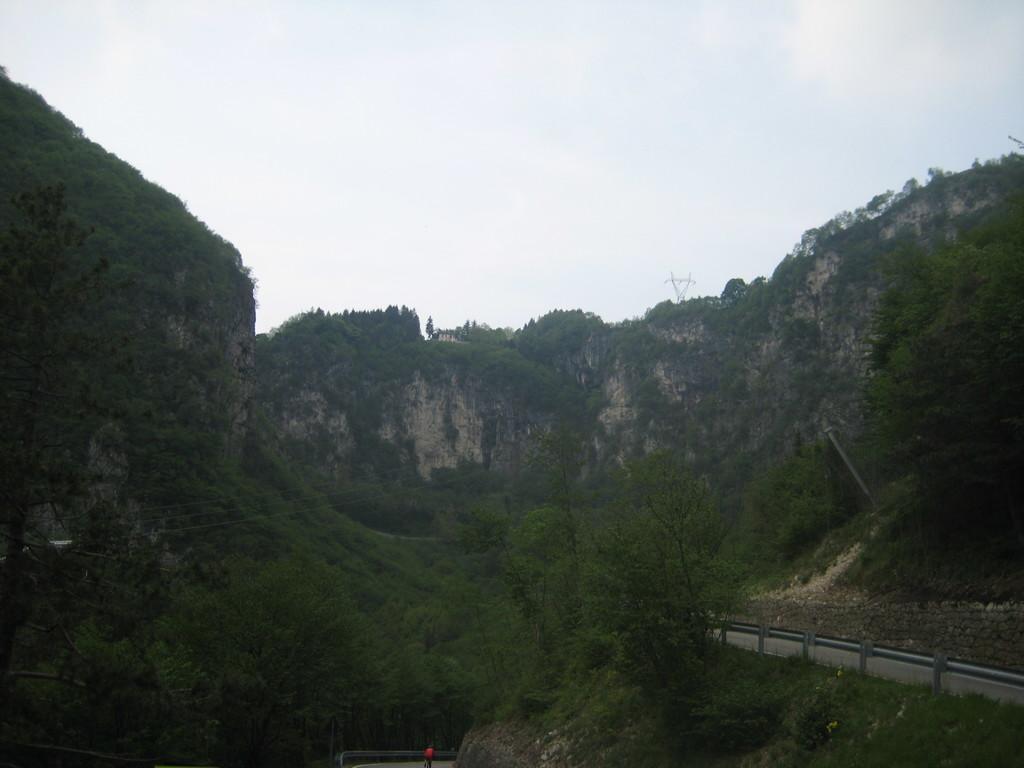How would you summarize this image in a sentence or two? In this image we can see trees, hill, wall and sky. 